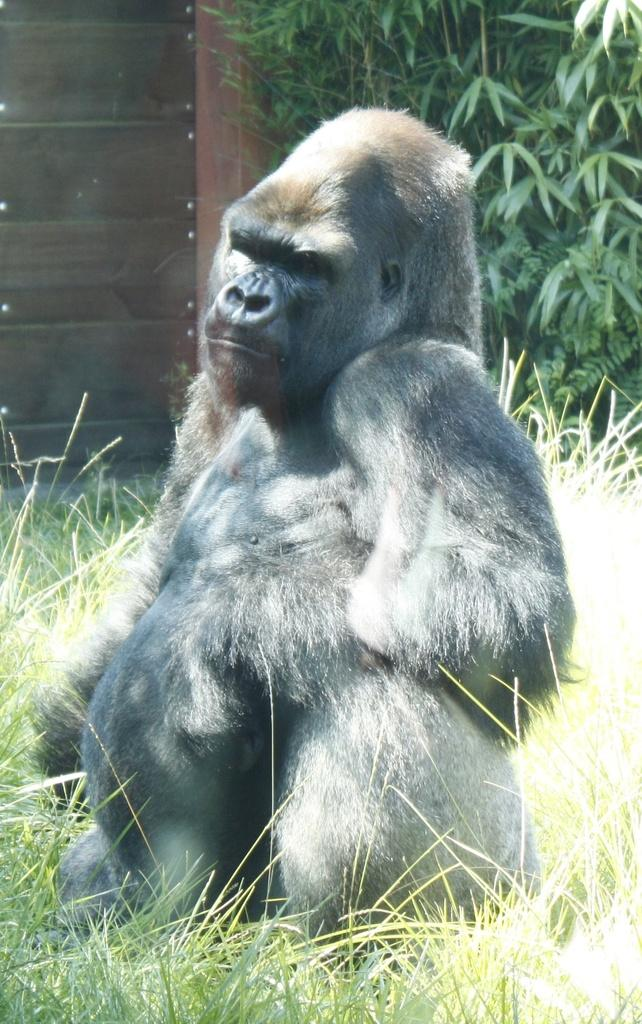What type of animal is in the image? The animal in the image is black in color. What can be seen in the background of the image? There are plants in the background of the image, and they are green in color. What material is the wooden object made of? The wooden object in the image is made of wood. What type of quilt is covering the animal in the image? There is no quilt present in the image; the animal is not covered by any fabric. 